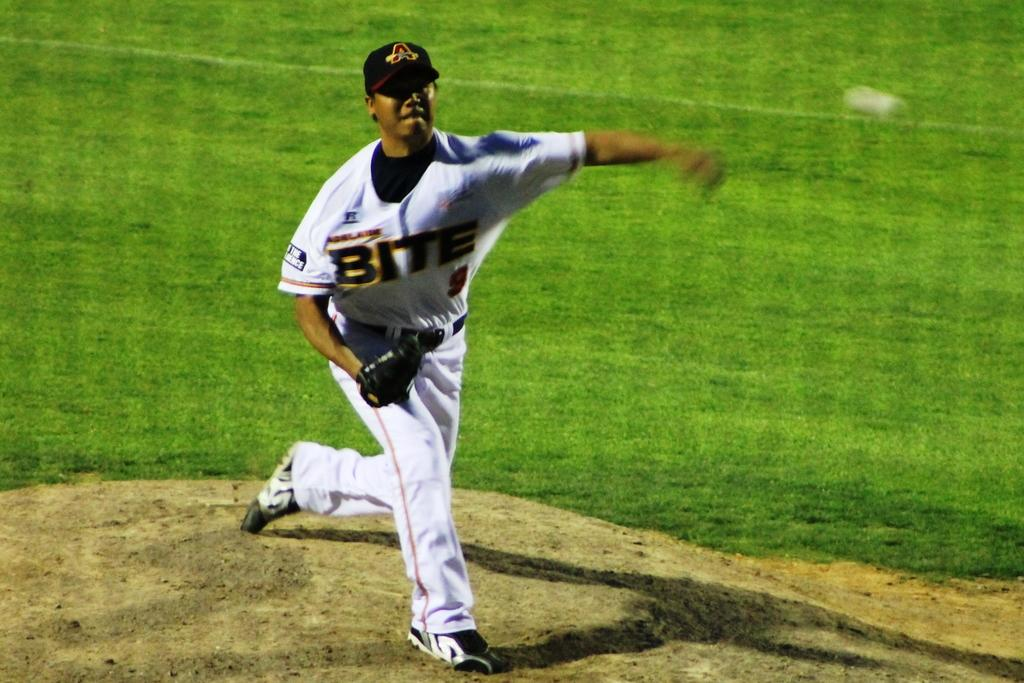Provide a one-sentence caption for the provided image. An Atlanta Braves baseball player throws a pitch. 